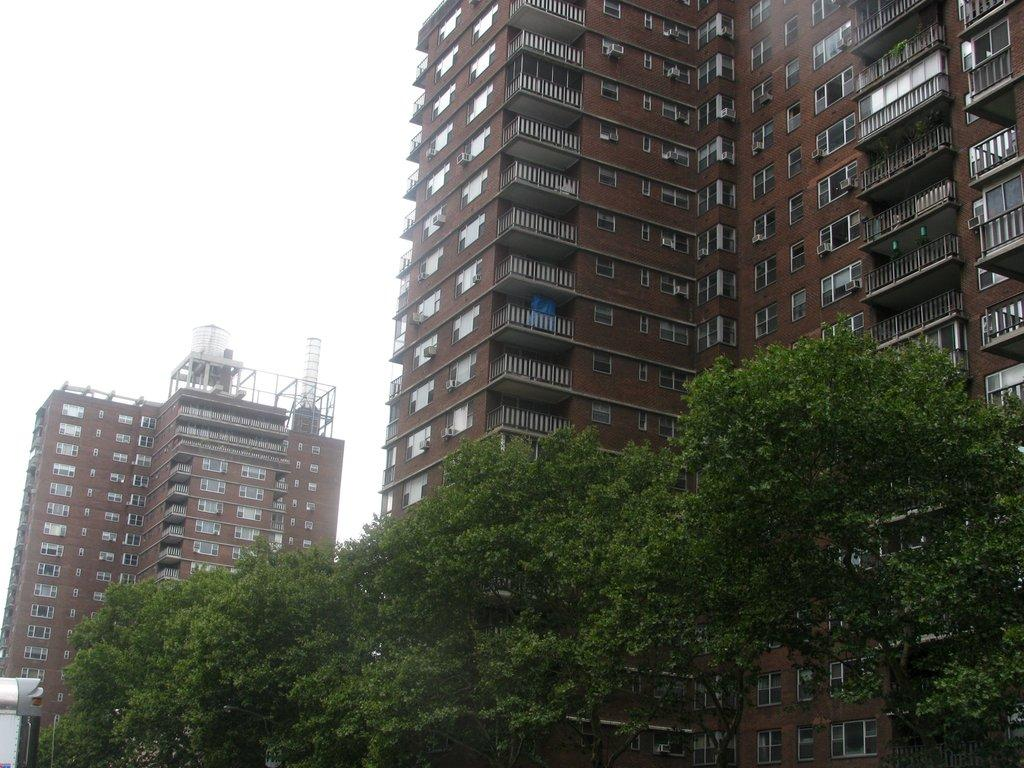What color are the buildings in the image? The buildings in the image are brown. What is located at the bottom of the image? There are trees at the bottom of the image. What can be seen at the top of the image? The sky is visible at the top of the image. Can you tell me how many strangers are interacting with the donkey in the image? There is no stranger or donkey present in the image. What type of memory can be seen in the image? There is no memory present in the image; it contains buildings, trees, and the sky. 